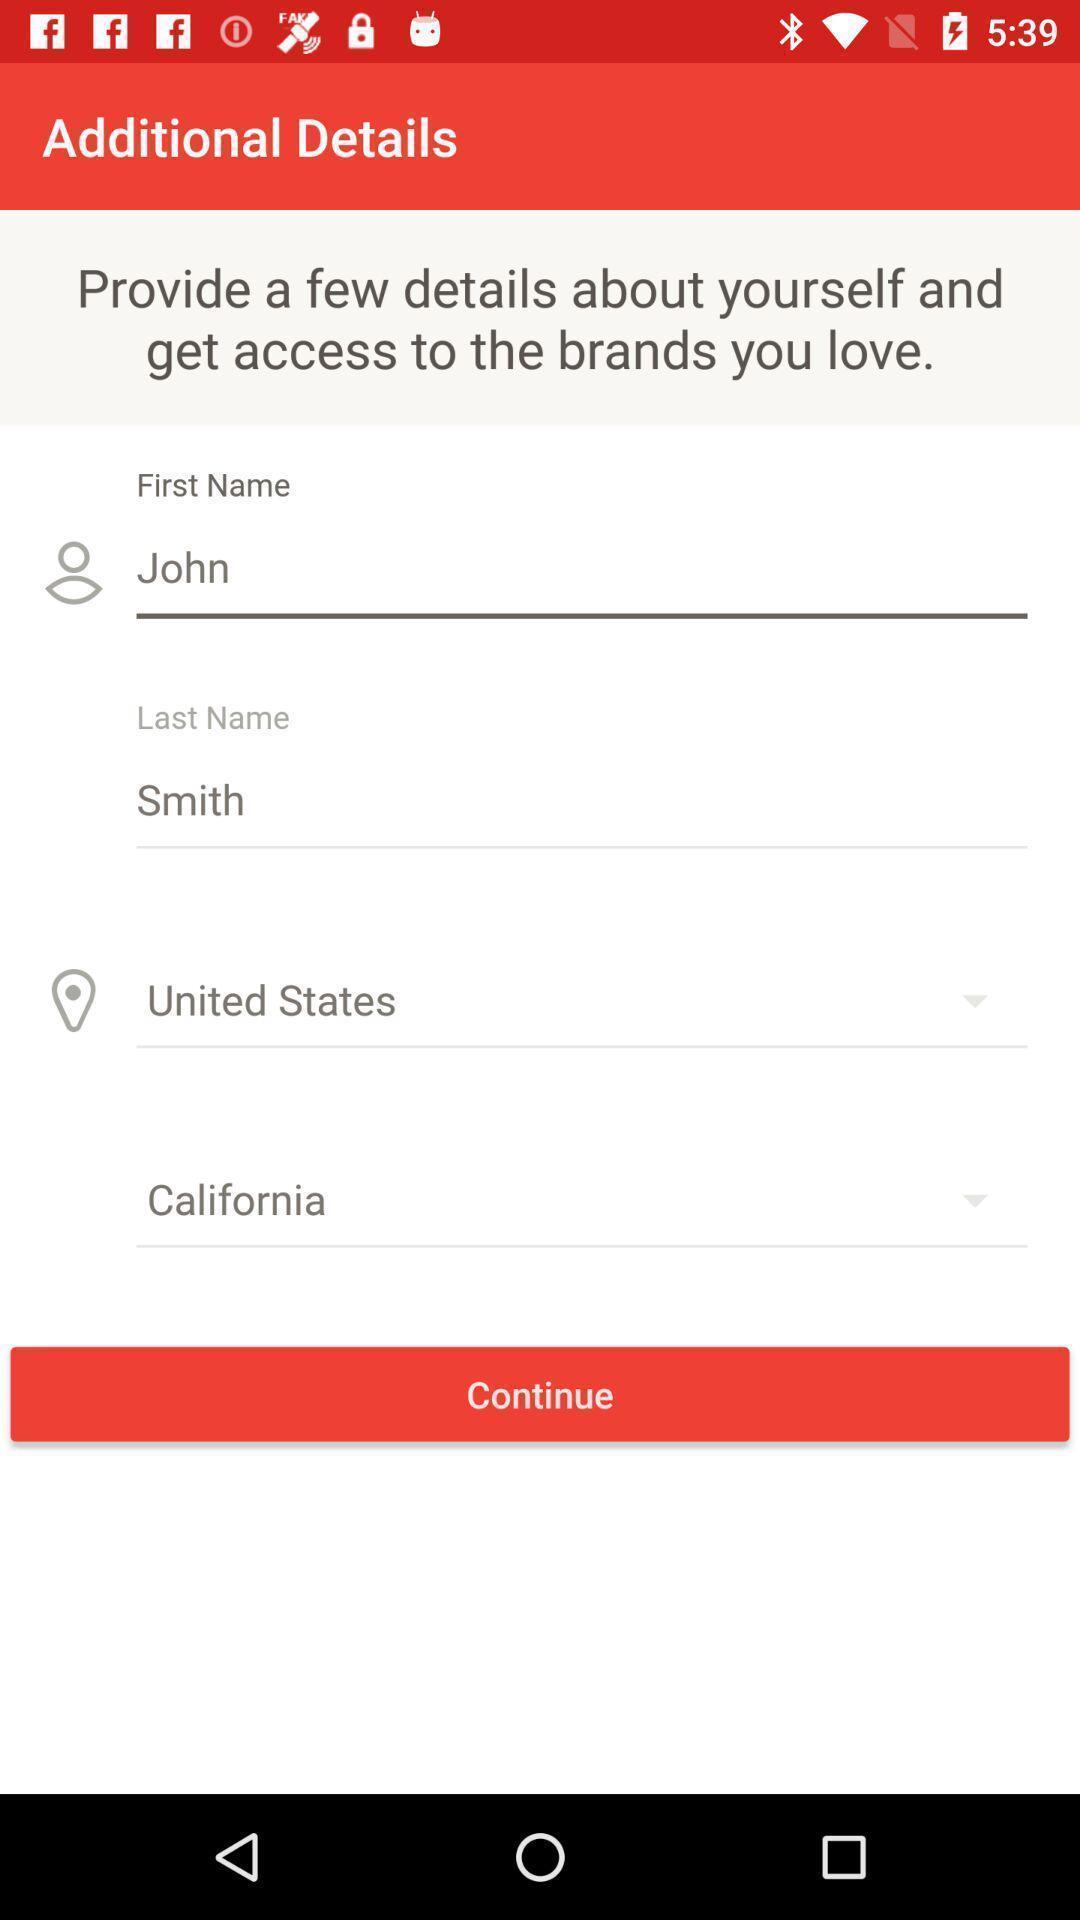Provide a detailed account of this screenshot. Screen shows additional details. 